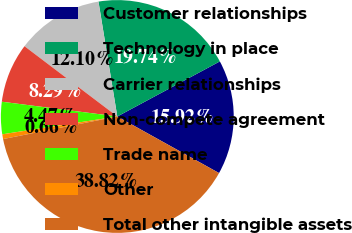Convert chart to OTSL. <chart><loc_0><loc_0><loc_500><loc_500><pie_chart><fcel>Customer relationships<fcel>Technology in place<fcel>Carrier relationships<fcel>Non-compete agreement<fcel>Trade name<fcel>Other<fcel>Total other intangible assets<nl><fcel>15.92%<fcel>19.74%<fcel>12.1%<fcel>8.29%<fcel>4.47%<fcel>0.66%<fcel>38.82%<nl></chart> 